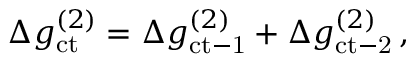Convert formula to latex. <formula><loc_0><loc_0><loc_500><loc_500>\begin{array} { r } { \Delta g _ { c t } ^ { ( 2 ) } = \Delta g _ { c t - 1 } ^ { ( 2 ) } + \Delta g _ { c t - 2 } ^ { ( 2 ) } \, , } \end{array}</formula> 